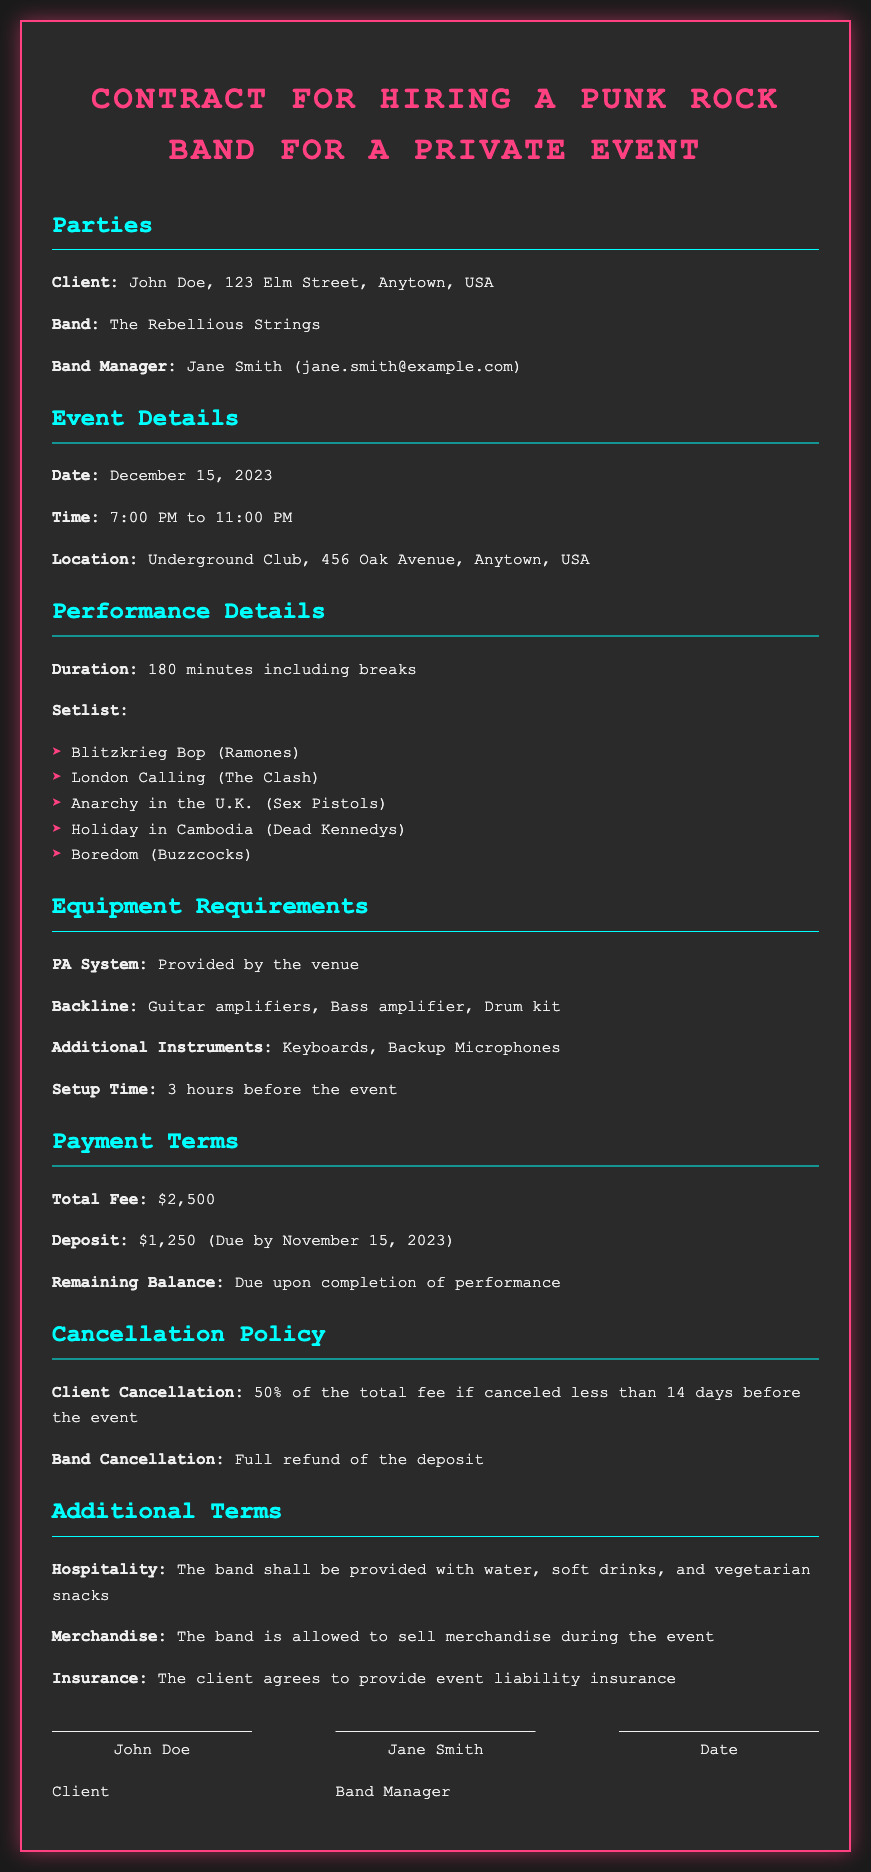what is the date of the event? The date of the event is clearly stated in the document as December 15, 2023.
Answer: December 15, 2023 who is the band manager? The document specifies that the band manager is Jane Smith.
Answer: Jane Smith how long is the performance duration? The performance duration mentioned in the document is 180 minutes.
Answer: 180 minutes what is the total fee for hiring the band? The contract lists the total fee for hiring the band as $2,500.
Answer: $2,500 what must be provided three hours before the event? According to the document, setup must be completed 3 hours before the event.
Answer: 3 hours before the event what is the penalty for client cancellation less than 14 days before the event? The document states that the penalty is 50% of the total fee for cancellations made less than 14 days before the event.
Answer: 50% of the total fee what kind of snacks should be provided for the band? The contract stipulates that vegetarian snacks should be provided for the band.
Answer: vegetarian snacks is the band allowed to sell merchandise at the event? The document confirms that the band is allowed to sell merchandise during the event.
Answer: allowed to sell merchandise what is the remaining balance due upon completion of performance? The contract indicates that the remaining balance is due upon completion of the performance.
Answer: upon completion of performance 